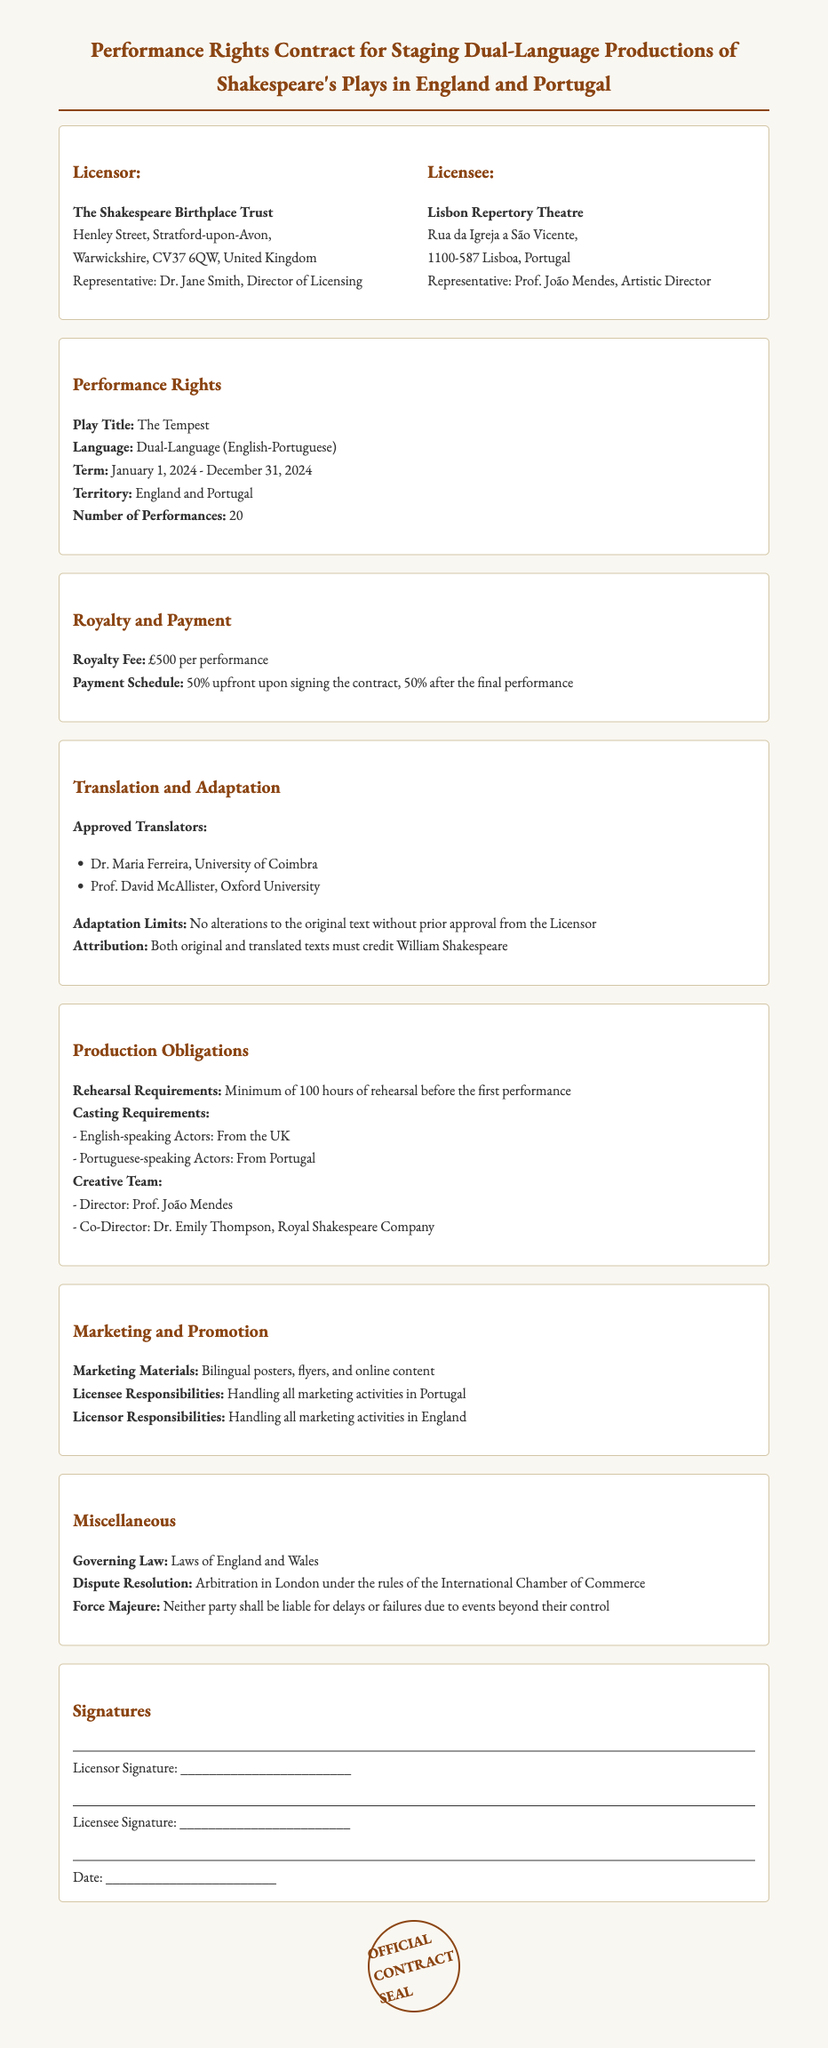What is the name of the Licensor? The Licensor is The Shakespeare Birthplace Trust, as indicated in the contract.
Answer: The Shakespeare Birthplace Trust What is the language of the performance? The language specified for the performance is dual-language (English-Portuguese).
Answer: Dual-Language (English-Portuguese) What is the royalty fee per performance? The document states that the royalty fee is £500 per performance.
Answer: £500 How many performances are allowed under this contract? The contract permits a total of 20 performances as outlined in the performance rights section.
Answer: 20 What is the term duration of the contract? The term duration is from January 1, 2024, to December 31, 2024, as specified in the performance rights section.
Answer: January 1, 2024 - December 31, 2024 What is the minimum rehearsal requirement? The contract stipulates a minimum of 100 hours of rehearsal before the first performance.
Answer: 100 hours Who is responsible for marketing activities in Portugal? The Licensee, Lisbon Repertory Theatre, is responsible for all marketing activities in Portugal as specified in the marketing section.
Answer: Lisbon Repertory Theatre Where will any disputes be arbitrated? The dispute resolution clause states that arbitration will take place in London under the rules of the International Chamber of Commerce.
Answer: London What are the names of the approved translators? The approved translators listed are Dr. Maria Ferreira and Prof. David McAllister.
Answer: Dr. Maria Ferreira, Prof. David McAllister 